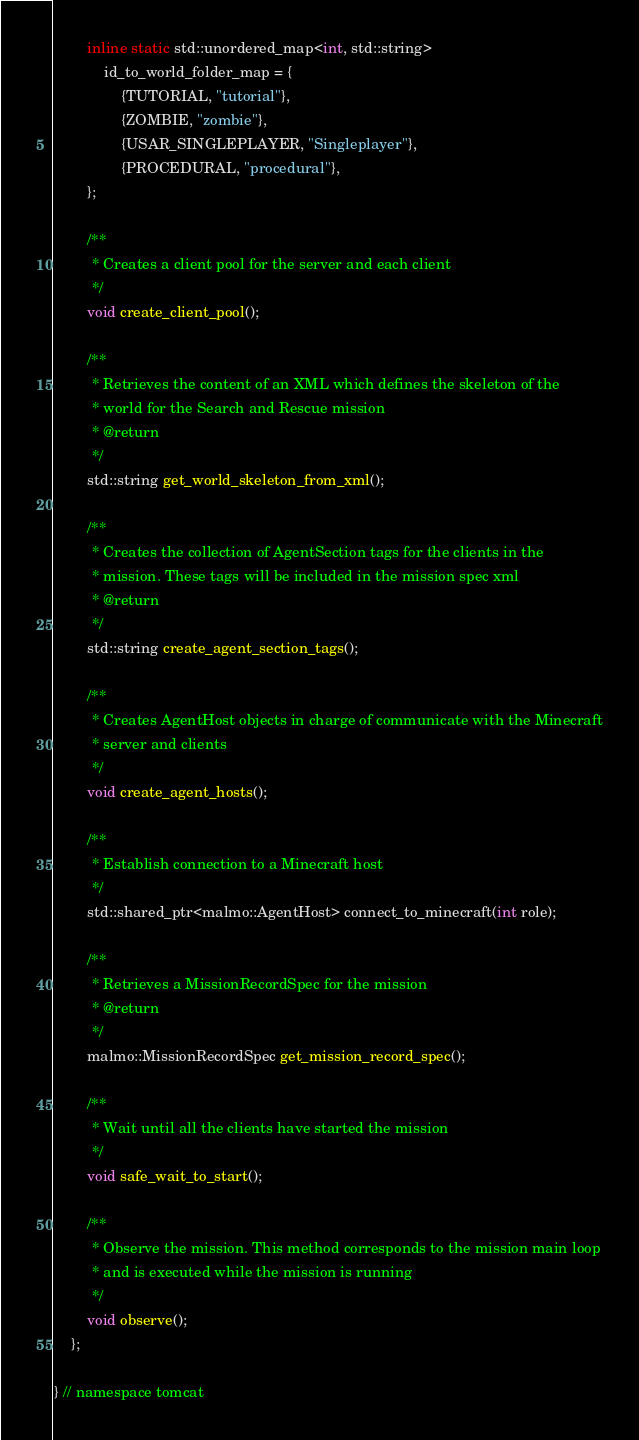Convert code to text. <code><loc_0><loc_0><loc_500><loc_500><_C_>        inline static std::unordered_map<int, std::string>
            id_to_world_folder_map = {
                {TUTORIAL, "tutorial"},
                {ZOMBIE, "zombie"},
                {USAR_SINGLEPLAYER, "Singleplayer"},
                {PROCEDURAL, "procedural"},
        };

        /**
         * Creates a client pool for the server and each client
         */
        void create_client_pool();

        /**
         * Retrieves the content of an XML which defines the skeleton of the
         * world for the Search and Rescue mission
         * @return
         */
        std::string get_world_skeleton_from_xml();

        /**
         * Creates the collection of AgentSection tags for the clients in the
         * mission. These tags will be included in the mission spec xml
         * @return
         */
        std::string create_agent_section_tags();

        /**
         * Creates AgentHost objects in charge of communicate with the Minecraft
         * server and clients
         */
        void create_agent_hosts();

        /**
         * Establish connection to a Minecraft host
         */
        std::shared_ptr<malmo::AgentHost> connect_to_minecraft(int role);

        /**
         * Retrieves a MissionRecordSpec for the mission
         * @return
         */
        malmo::MissionRecordSpec get_mission_record_spec();

        /**
         * Wait until all the clients have started the mission
         */
        void safe_wait_to_start();

        /**
         * Observe the mission. This method corresponds to the mission main loop
         * and is executed while the mission is running
         */
        void observe();
    };

} // namespace tomcat
</code> 